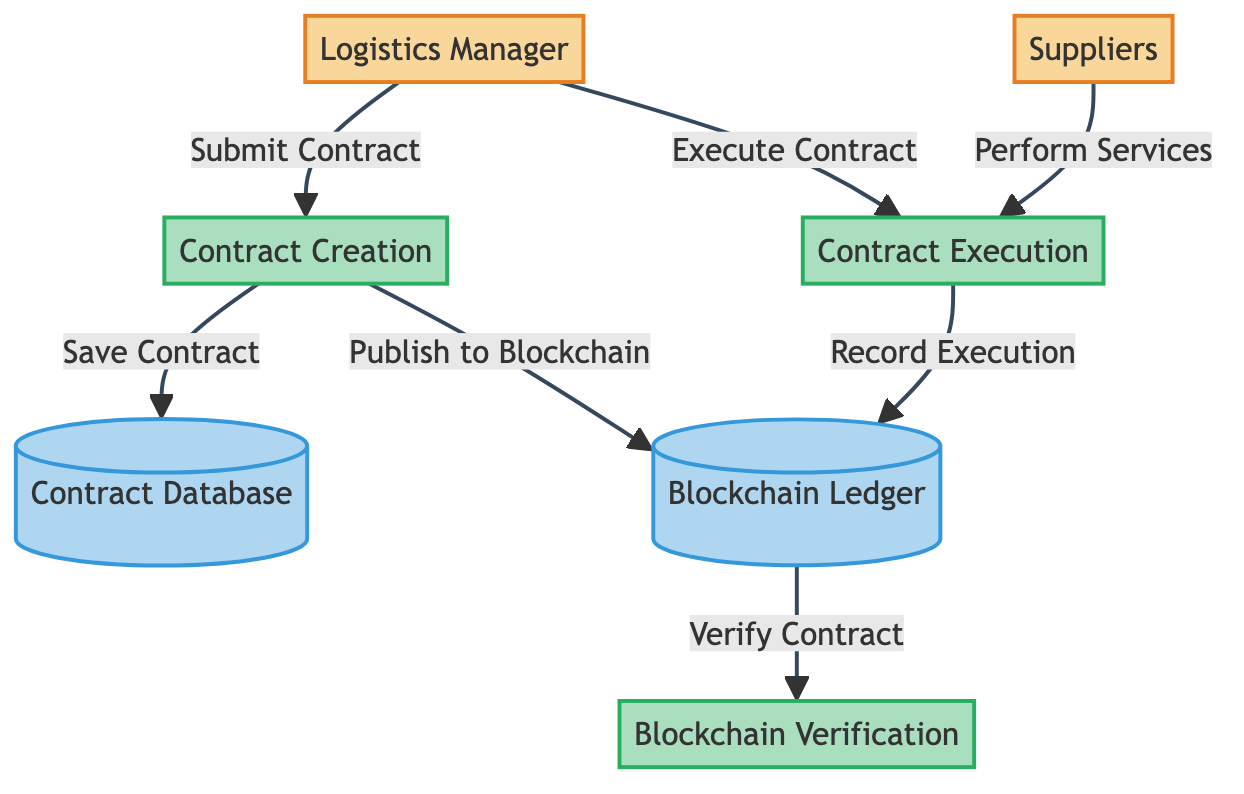What is the first step in the contract management process? The first step in the process is initiated by the Logistics Manager who submits a contract to the Contract Creation process.
Answer: Submit Contract How many processes are involved in the diagram? The diagram includes three processes: Contract Creation, Blockchain Verification, and Contract Execution.
Answer: Three processes Which entity is responsible for executing the contract? The Logistics Manager initiates the execution of the contract as indicated by the flow from the Logistics Manager to the Contract Execution process.
Answer: Logistics Manager What does the Blockchain Ledger store? The Blockchain Ledger maintains an immutable record of all contracts and transactions, as specified in the description of this data store.
Answer: All contracts and transactions What flow follows after the Blockchain Verification process? The next flow after Blockchain Verification is the Execute Contract flow from the Logistics Manager to Contract Execution, where the execution is carried out based on the verified contract.
Answer: Execute Contract What document is saved to the Contract Database? The created contract, after its details are defined in the Contract Creation process, is saved to the Contract Database.
Answer: Created contract How do Suppliers contribute to the Contract Execution? Suppliers perform services or deliver goods as per the contract, as indicated by the flow from Suppliers to the Contract Execution process.
Answer: Perform services Which process ensures immutability and trust? The Blockchain Verification process is specifically designed to ensure the contract details are verified, which guarantees immutability and trust.
Answer: Blockchain Verification What happens after a contract is published to the Blockchain Ledger? After a contract is published to the Blockchain Ledger, it undergoes verification in the Blockchain Verification process to check the contract details.
Answer: Verify Contract What is the relationship between Contract Execution and Blockchain Ledger? The Contract Execution process records details of the execution back to the Blockchain Ledger, ensuring that all contract executions are captured immutably.
Answer: Record Execution 